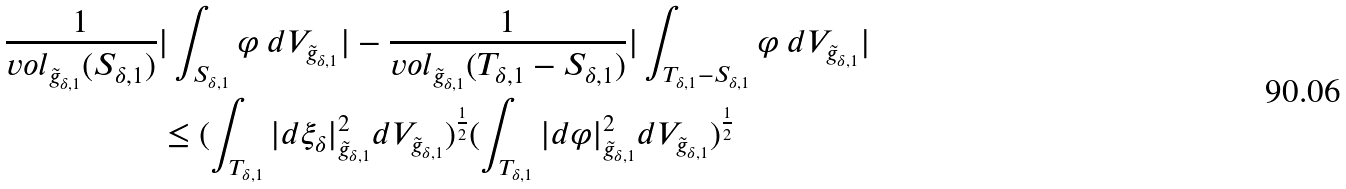Convert formula to latex. <formula><loc_0><loc_0><loc_500><loc_500>\frac { 1 } { v o l _ { \tilde { g } _ { \delta , 1 } } ( S _ { \delta , 1 } ) } & | \int _ { S _ { \delta , 1 } } \varphi \ d V _ { \tilde { g } _ { \delta , 1 } } | - \frac { 1 } { v o l _ { \tilde { g } _ { \delta , 1 } } ( T _ { \delta , 1 } - S _ { \delta , 1 } ) } | \int _ { T _ { \delta , 1 } - S _ { \delta , 1 } } \varphi \ d V _ { \tilde { g } _ { \delta , 1 } } | \\ & \leq ( \int _ { T _ { \delta , 1 } } | d \xi _ { \delta } | ^ { 2 } _ { \tilde { g } _ { \delta , 1 } } d V _ { \tilde { g } _ { \delta , 1 } } ) ^ { \frac { 1 } { 2 } } ( \int _ { T _ { \delta , 1 } } | d \varphi | ^ { 2 } _ { \tilde { g } _ { \delta , 1 } } d V _ { \tilde { g } _ { \delta , 1 } } ) ^ { \frac { 1 } { 2 } }</formula> 